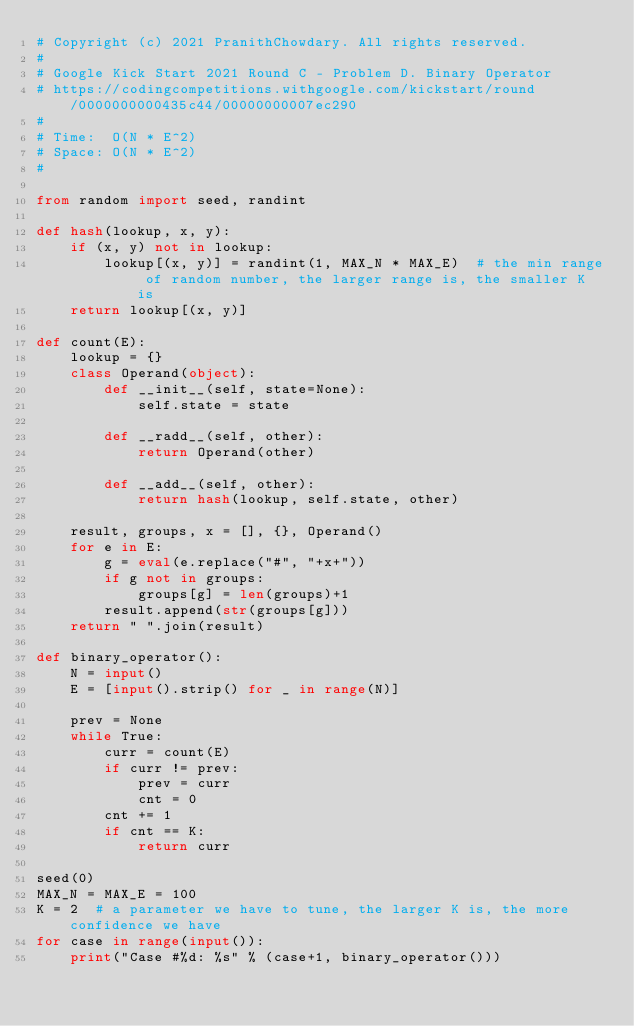Convert code to text. <code><loc_0><loc_0><loc_500><loc_500><_Python_># Copyright (c) 2021 PranithChowdary. All rights reserved.
#
# Google Kick Start 2021 Round C - Problem D. Binary Operator
# https://codingcompetitions.withgoogle.com/kickstart/round/0000000000435c44/00000000007ec290
#
# Time:  O(N * E^2)
# Space: O(N * E^2)
#

from random import seed, randint

def hash(lookup, x, y):
    if (x, y) not in lookup:
        lookup[(x, y)] = randint(1, MAX_N * MAX_E)  # the min range of random number, the larger range is, the smaller K is
    return lookup[(x, y)]    

def count(E):
    lookup = {}
    class Operand(object):
        def __init__(self, state=None):
            self.state = state

        def __radd__(self, other):
            return Operand(other)

        def __add__(self, other):
            return hash(lookup, self.state, other)

    result, groups, x = [], {}, Operand()
    for e in E:
        g = eval(e.replace("#", "+x+"))
        if g not in groups:
            groups[g] = len(groups)+1
        result.append(str(groups[g]))
    return " ".join(result)

def binary_operator():
    N = input()
    E = [input().strip() for _ in range(N)]

    prev = None
    while True:
        curr = count(E)
        if curr != prev:
            prev = curr
            cnt = 0
        cnt += 1
        if cnt == K:
            return curr

seed(0)
MAX_N = MAX_E = 100
K = 2  # a parameter we have to tune, the larger K is, the more confidence we have
for case in range(input()):
    print("Case #%d: %s" % (case+1, binary_operator()))
</code> 